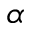<formula> <loc_0><loc_0><loc_500><loc_500>\alpha</formula> 